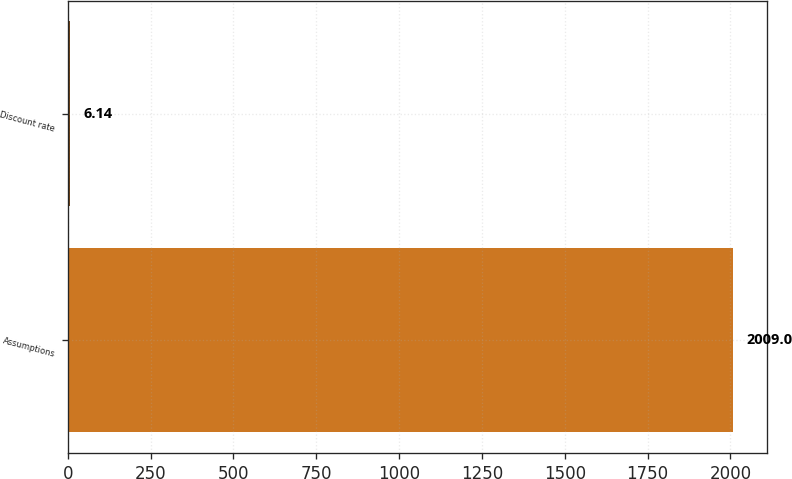<chart> <loc_0><loc_0><loc_500><loc_500><bar_chart><fcel>Assumptions<fcel>Discount rate<nl><fcel>2009<fcel>6.14<nl></chart> 